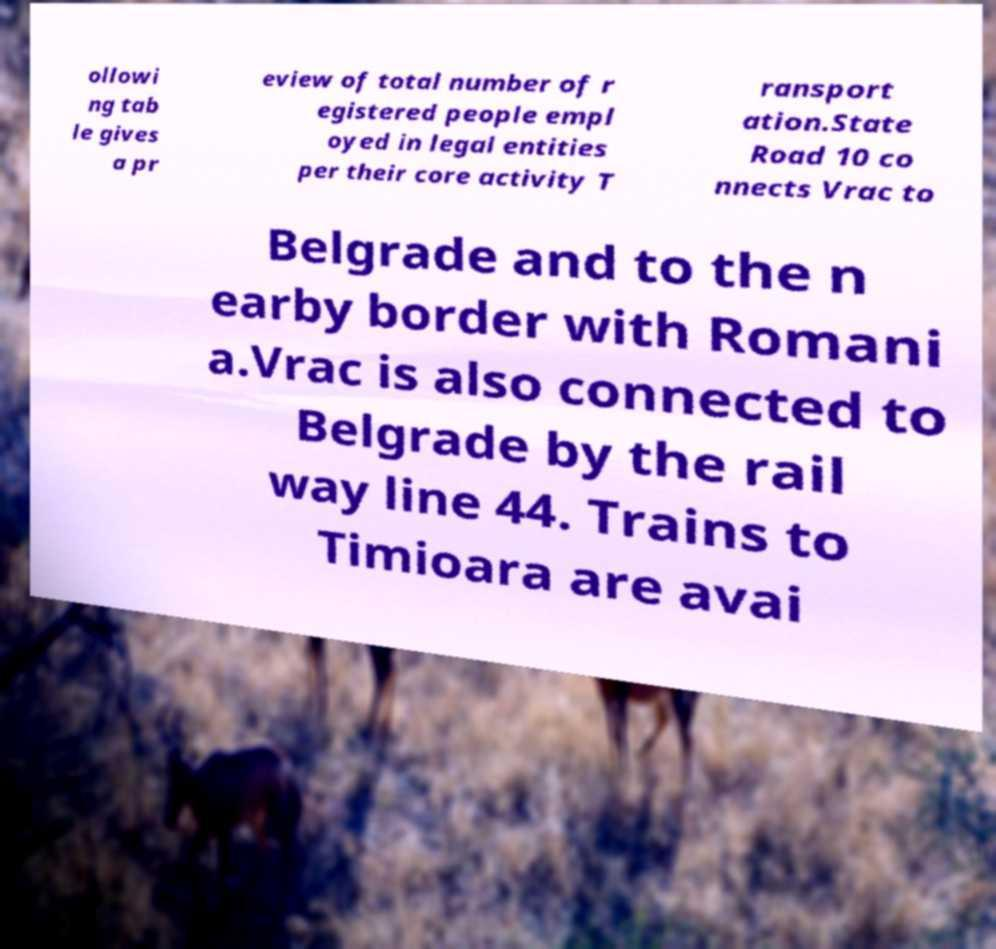I need the written content from this picture converted into text. Can you do that? ollowi ng tab le gives a pr eview of total number of r egistered people empl oyed in legal entities per their core activity T ransport ation.State Road 10 co nnects Vrac to Belgrade and to the n earby border with Romani a.Vrac is also connected to Belgrade by the rail way line 44. Trains to Timioara are avai 